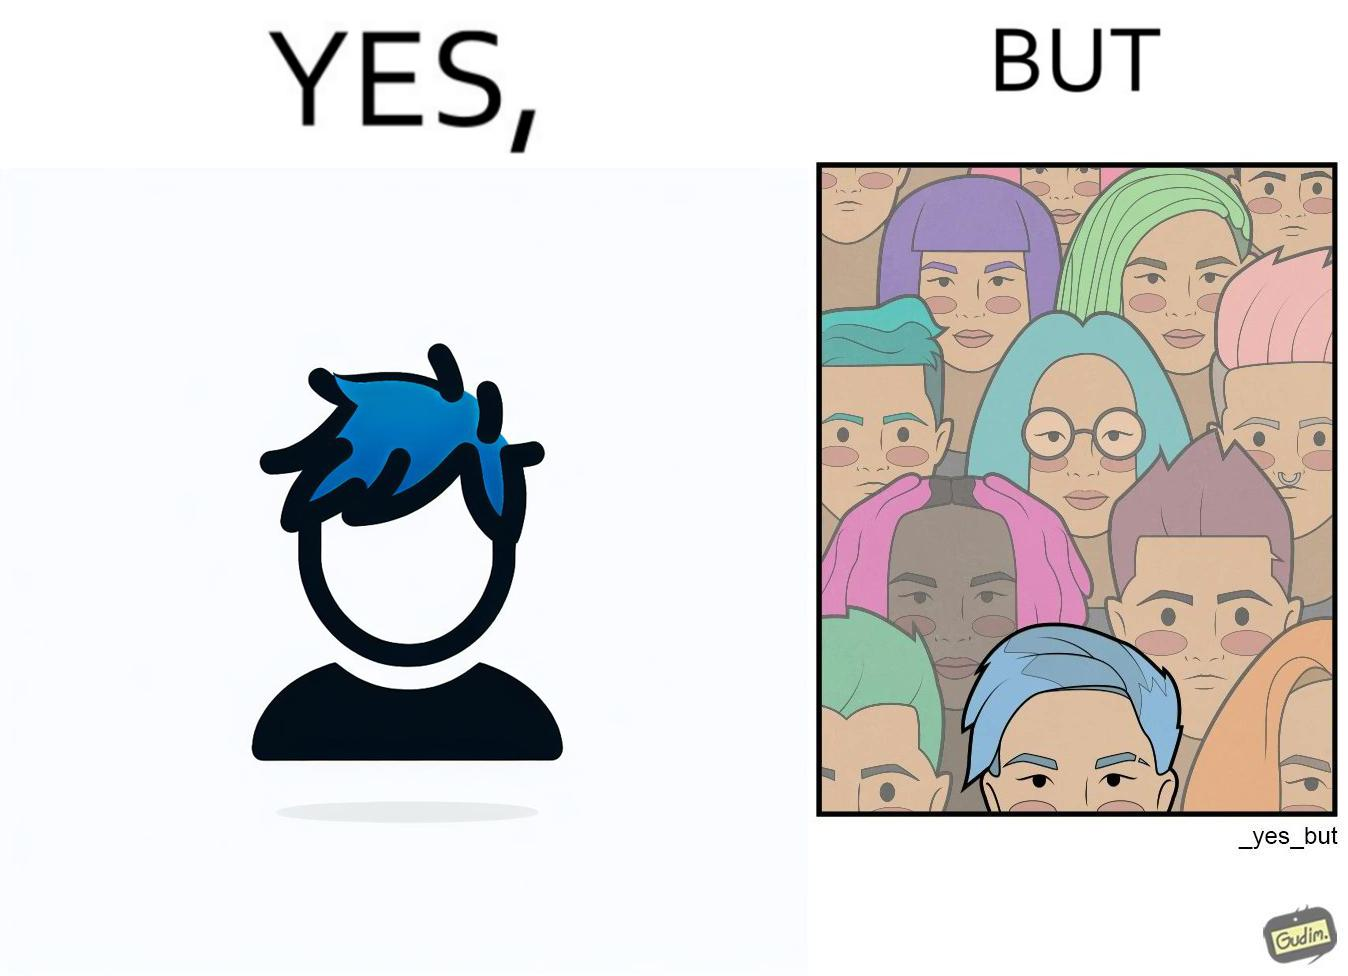Describe what you see in the left and right parts of this image. In the left part of the image: a person with hair dyed blue. In the right part of the image: a group of people having hair dyed in different colors. 